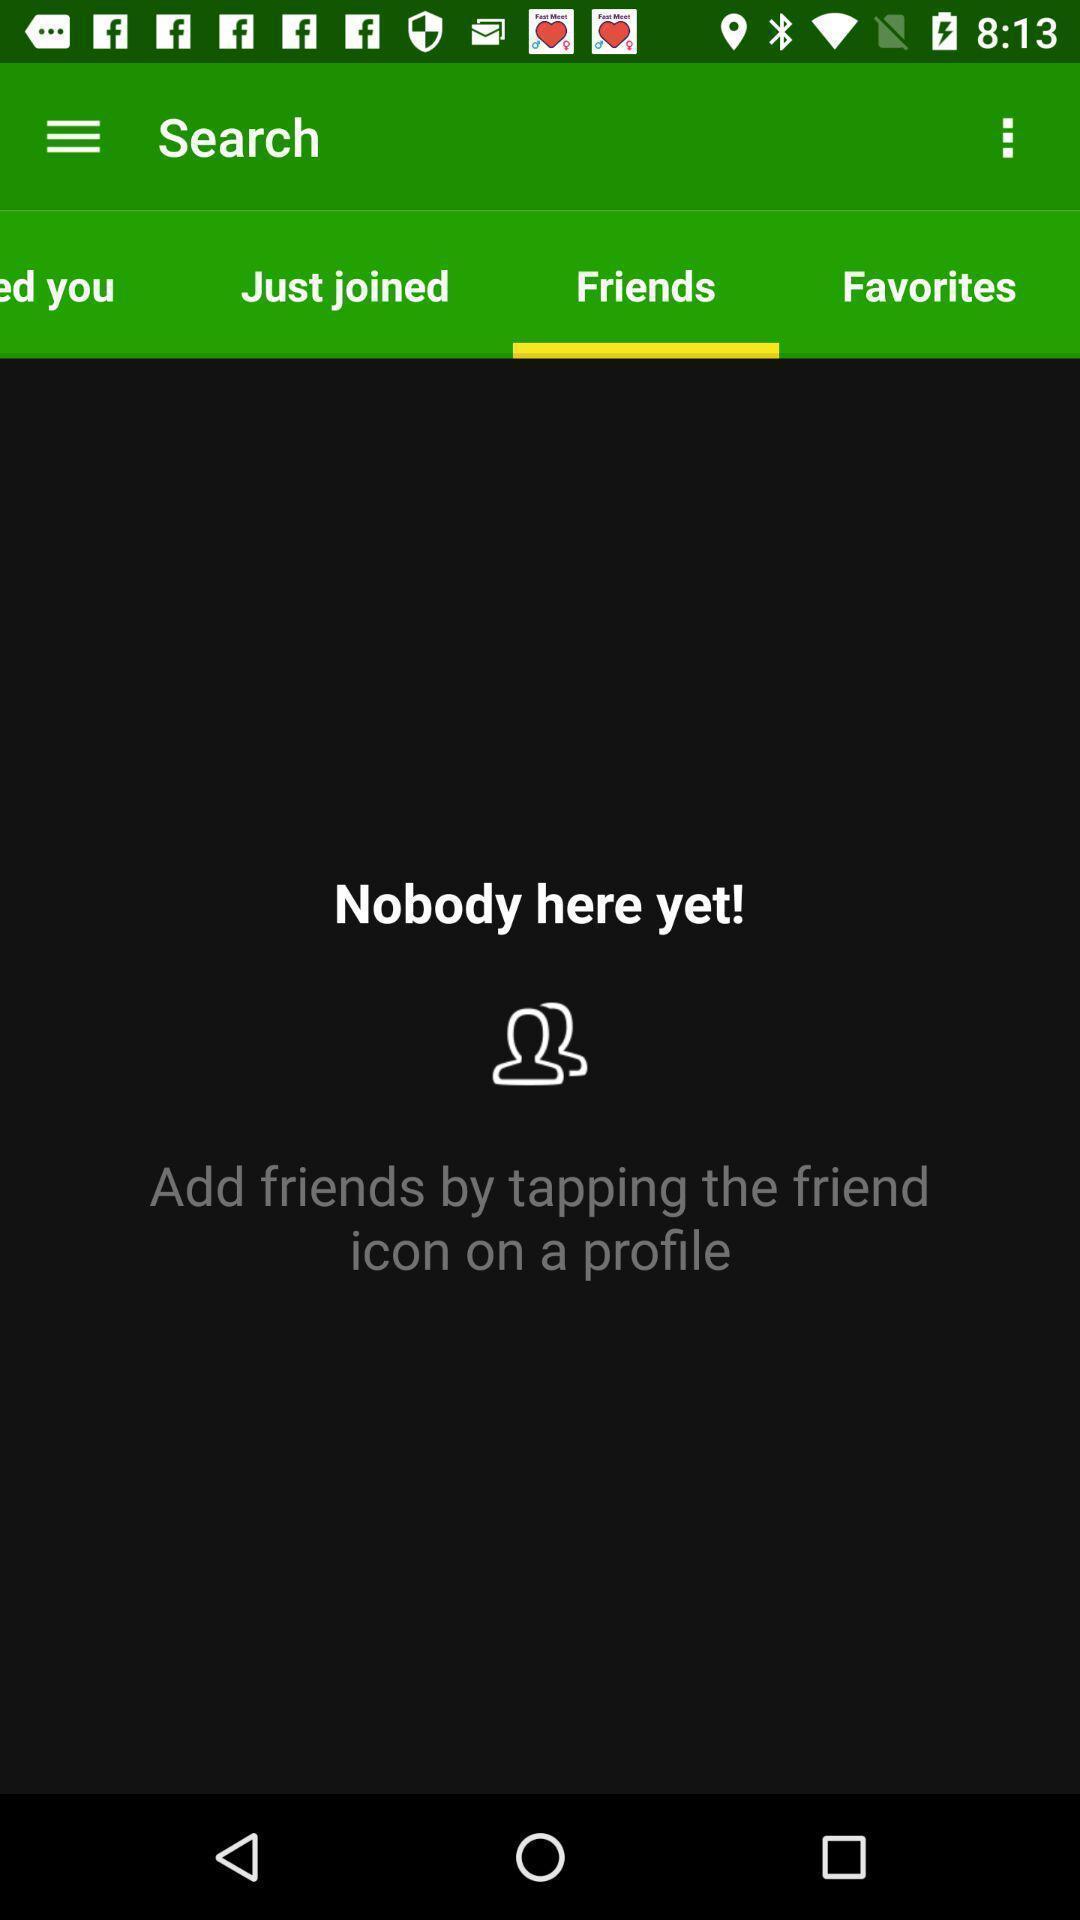Describe the visual elements of this screenshot. Screen displaying friends page of a social media app. 